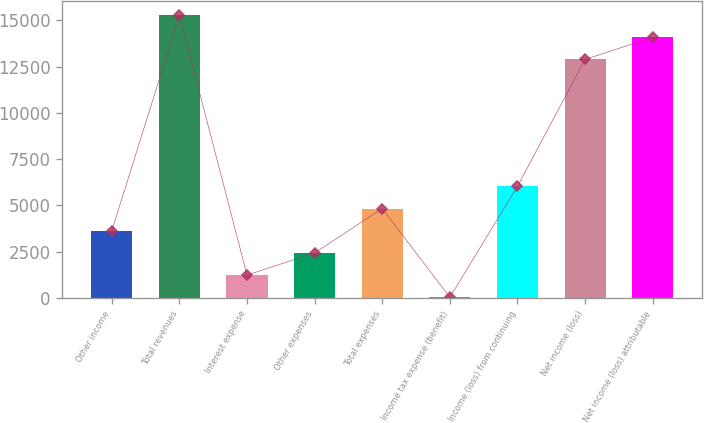Convert chart to OTSL. <chart><loc_0><loc_0><loc_500><loc_500><bar_chart><fcel>Other income<fcel>Total revenues<fcel>Interest expense<fcel>Other expenses<fcel>Total expenses<fcel>Income tax expense (benefit)<fcel>Income (loss) from continuing<fcel>Net income (loss)<fcel>Net income (loss) attributable<nl><fcel>3624.3<fcel>15287.3<fcel>1224.1<fcel>2424.2<fcel>4824.4<fcel>24<fcel>6024.5<fcel>12887.1<fcel>14087.2<nl></chart> 